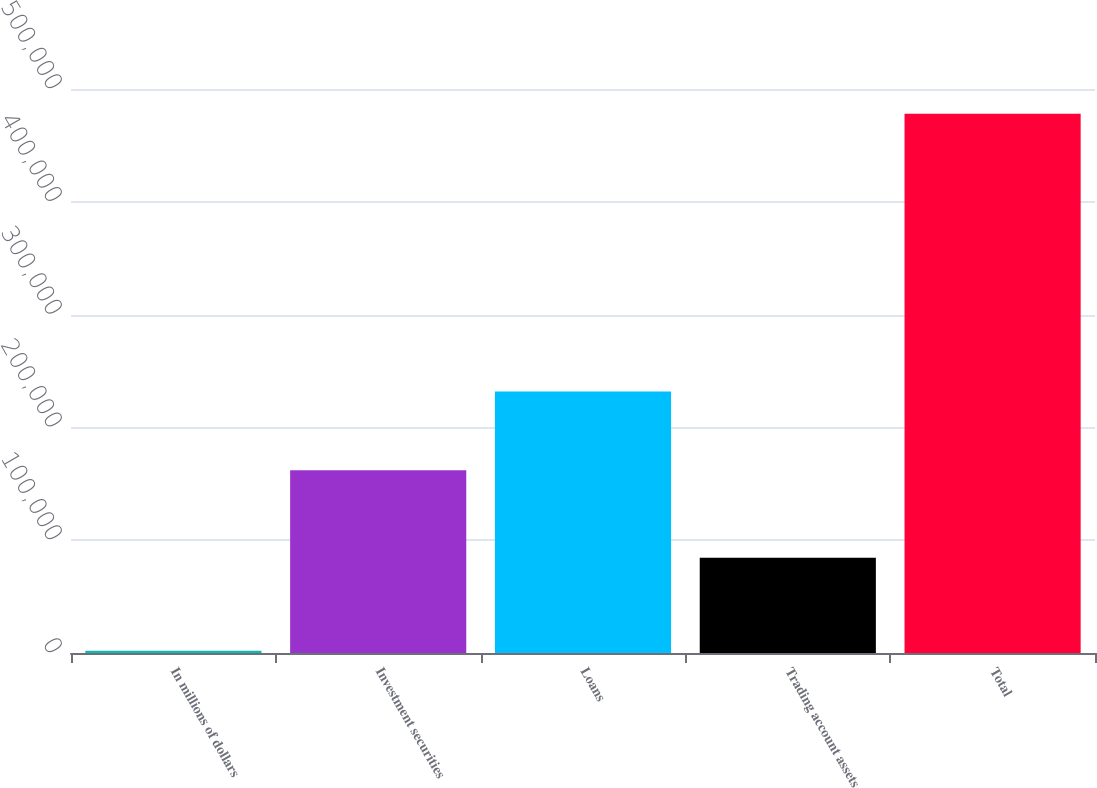Convert chart to OTSL. <chart><loc_0><loc_0><loc_500><loc_500><bar_chart><fcel>In millions of dollars<fcel>Investment securities<fcel>Loans<fcel>Trading account assets<fcel>Total<nl><fcel>2016<fcel>161914<fcel>231833<fcel>84371<fcel>478118<nl></chart> 